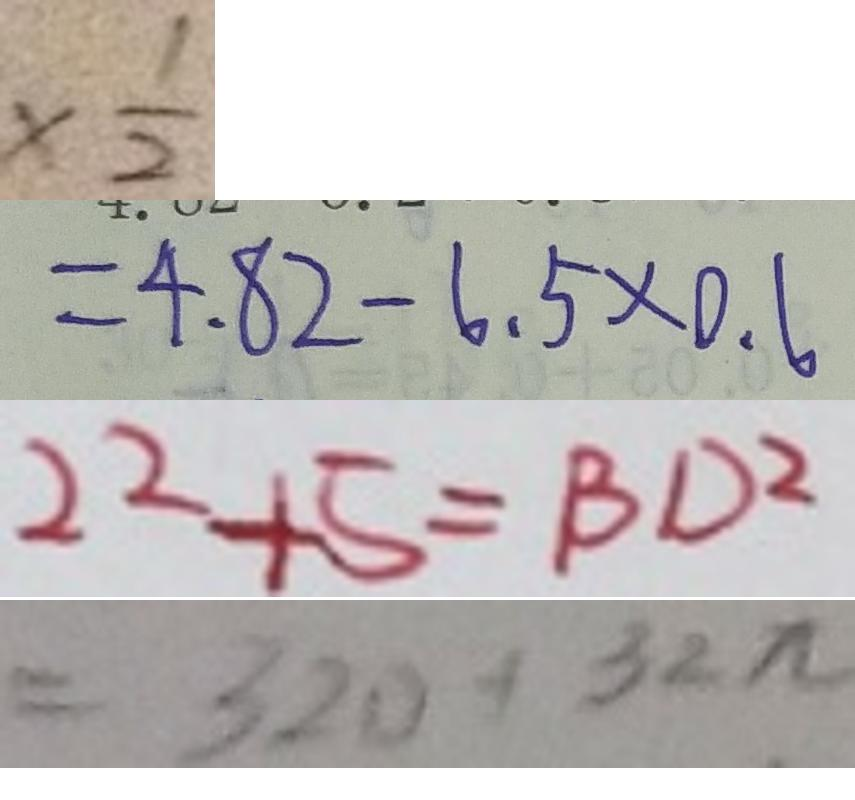<formula> <loc_0><loc_0><loc_500><loc_500>\times \frac { 1 } { 2 } 
 = 4 . 8 2 - 6 . 5 \times 0 . 6 
 2 2 + 5 = B D ^ { 2 } 
 = 3 2 0 + 3 2 \pi</formula> 